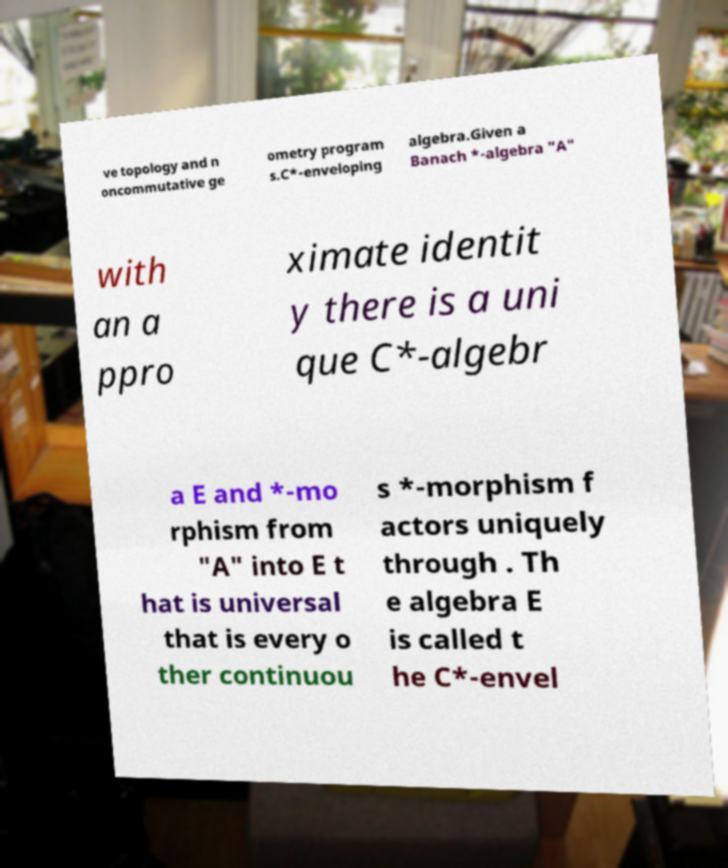Please identify and transcribe the text found in this image. ve topology and n oncommutative ge ometry program s.C*-enveloping algebra.Given a Banach *-algebra "A" with an a ppro ximate identit y there is a uni que C*-algebr a E and *-mo rphism from "A" into E t hat is universal that is every o ther continuou s *-morphism f actors uniquely through . Th e algebra E is called t he C*-envel 